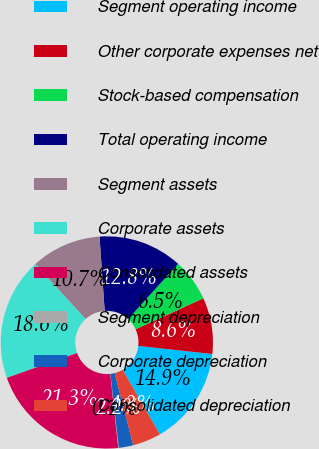Convert chart. <chart><loc_0><loc_0><loc_500><loc_500><pie_chart><fcel>Segment operating income<fcel>Other corporate expenses net<fcel>Stock-based compensation<fcel>Total operating income<fcel>Segment assets<fcel>Corporate assets<fcel>Consolidated assets<fcel>Segment depreciation<fcel>Corporate depreciation<fcel>Consolidated depreciation<nl><fcel>14.94%<fcel>8.57%<fcel>6.45%<fcel>12.82%<fcel>10.69%<fcel>18.62%<fcel>21.31%<fcel>0.08%<fcel>2.2%<fcel>4.32%<nl></chart> 